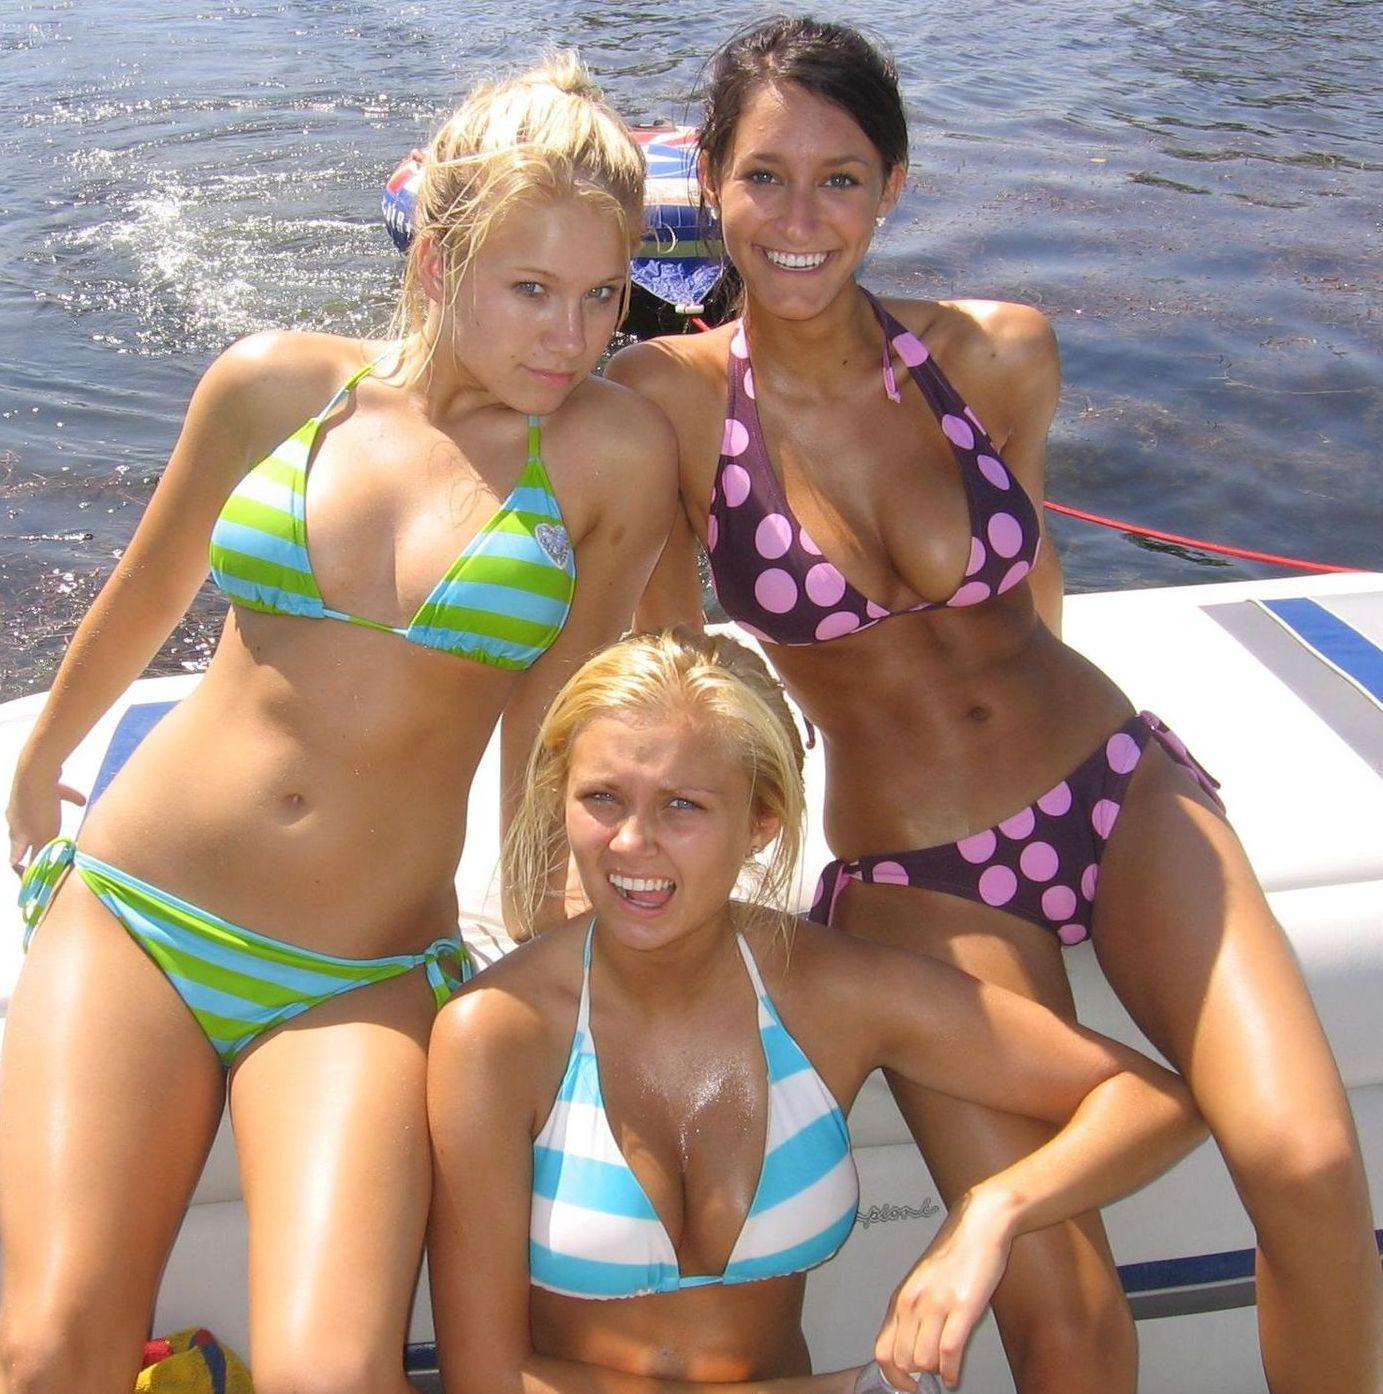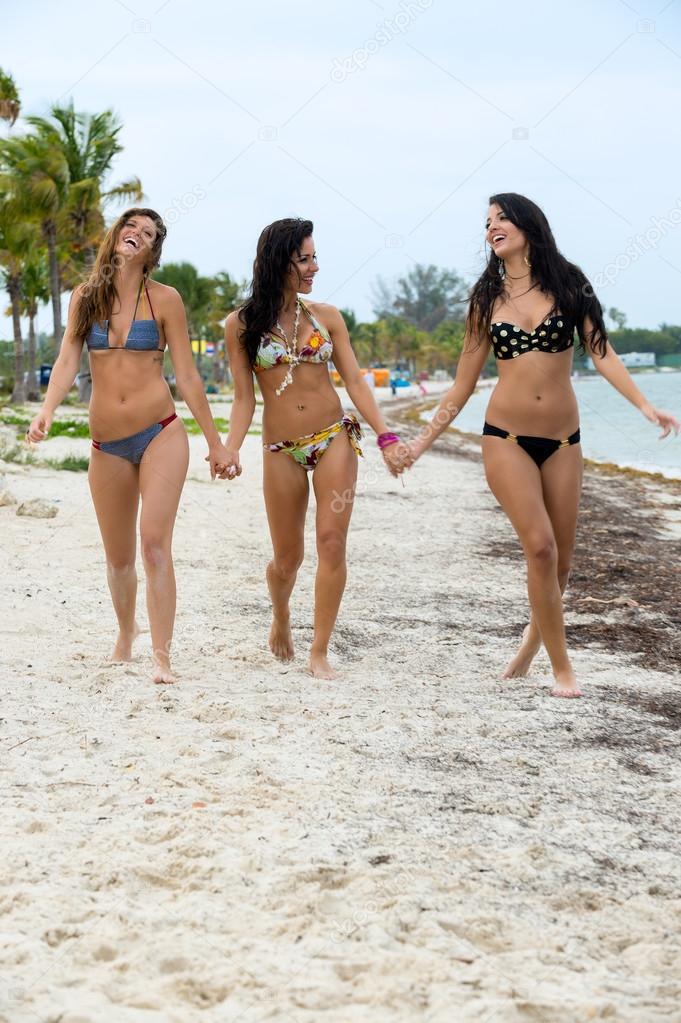The first image is the image on the left, the second image is the image on the right. Considering the images on both sides, is "An image shows three bikini models, with the one on the far right wearing a polka-dotted black top." valid? Answer yes or no. Yes. 